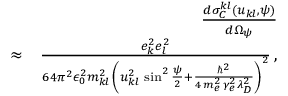<formula> <loc_0><loc_0><loc_500><loc_500>\begin{array} { r l r } & { \frac { d \sigma _ { C } ^ { k l } \left ( u _ { k l } , \psi \right ) } { d \Omega _ { \psi } } } \\ & { \approx } & { \frac { e _ { k } ^ { 2 } e _ { l } ^ { 2 } } { 6 4 \pi ^ { 2 } \epsilon _ { 0 } ^ { 2 } m _ { k l } ^ { 2 } \, \left ( u _ { k l } ^ { 2 } \, \sin ^ { 2 } \frac { \psi } { 2 } + \frac { \hbar { ^ } { 2 } } { 4 \, m _ { e } ^ { 2 } \, \gamma _ { e } ^ { 2 } \lambda _ { D } ^ { 2 } } \right ) ^ { 2 } } \, , } \end{array}</formula> 